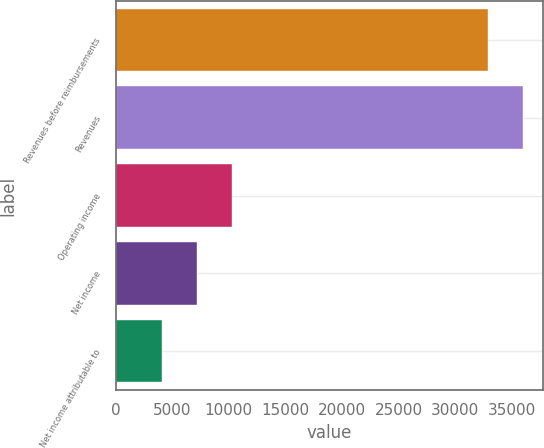Convert chart to OTSL. <chart><loc_0><loc_0><loc_500><loc_500><bar_chart><fcel>Revenues before reimbursements<fcel>Revenues<fcel>Operating income<fcel>Net income<fcel>Net income attributable to<nl><fcel>32883<fcel>35951.6<fcel>10249.2<fcel>7180.6<fcel>4112<nl></chart> 